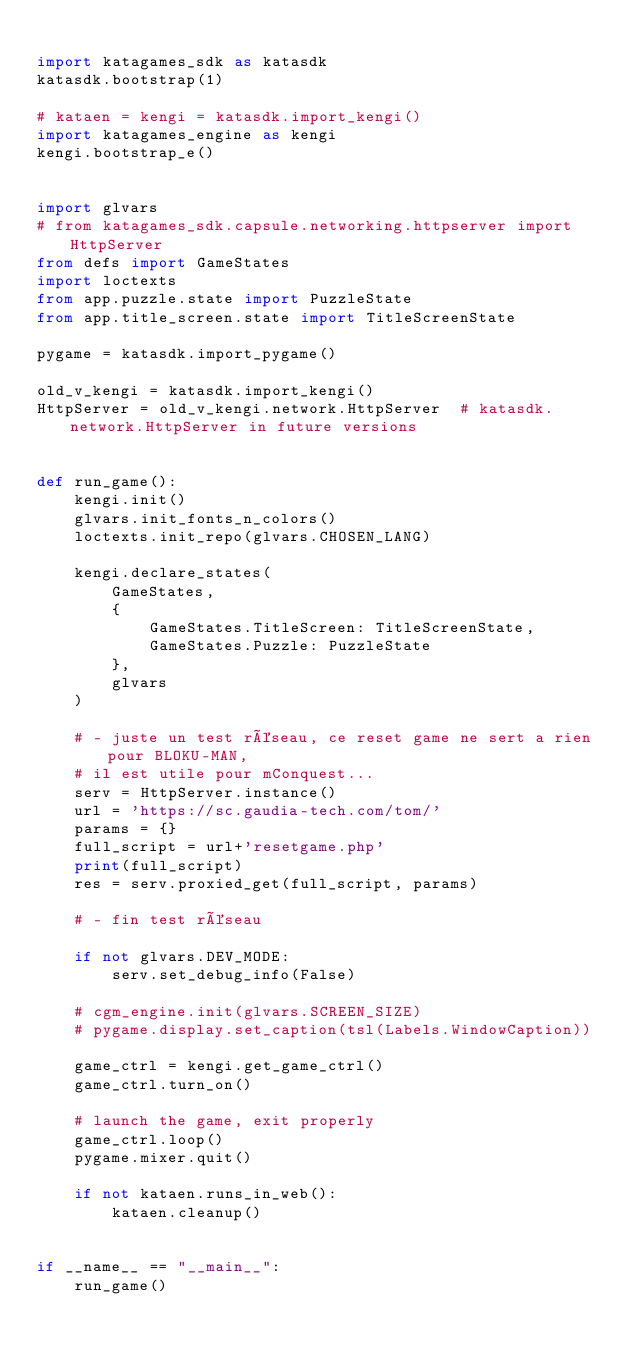Convert code to text. <code><loc_0><loc_0><loc_500><loc_500><_Python_>
import katagames_sdk as katasdk
katasdk.bootstrap(1)

# kataen = kengi = katasdk.import_kengi()
import katagames_engine as kengi
kengi.bootstrap_e()


import glvars
# from katagames_sdk.capsule.networking.httpserver import HttpServer
from defs import GameStates
import loctexts
from app.puzzle.state import PuzzleState
from app.title_screen.state import TitleScreenState

pygame = katasdk.import_pygame()

old_v_kengi = katasdk.import_kengi()
HttpServer = old_v_kengi.network.HttpServer  # katasdk.network.HttpServer in future versions


def run_game():
    kengi.init()
    glvars.init_fonts_n_colors()
    loctexts.init_repo(glvars.CHOSEN_LANG)

    kengi.declare_states(
        GameStates,
        {
            GameStates.TitleScreen: TitleScreenState,
            GameStates.Puzzle: PuzzleState
        },
        glvars
    )

    # - juste un test réseau, ce reset game ne sert a rien pour BLOKU-MAN,
    # il est utile pour mConquest...
    serv = HttpServer.instance()
    url = 'https://sc.gaudia-tech.com/tom/'
    params = {}
    full_script = url+'resetgame.php'
    print(full_script)
    res = serv.proxied_get(full_script, params)

    # - fin test réseau

    if not glvars.DEV_MODE:
        serv.set_debug_info(False)
    
    # cgm_engine.init(glvars.SCREEN_SIZE)
    # pygame.display.set_caption(tsl(Labels.WindowCaption))

    game_ctrl = kengi.get_game_ctrl()
    game_ctrl.turn_on()

    # launch the game, exit properly
    game_ctrl.loop()
    pygame.mixer.quit()

    if not kataen.runs_in_web():
        kataen.cleanup()


if __name__ == "__main__":
    run_game()
</code> 